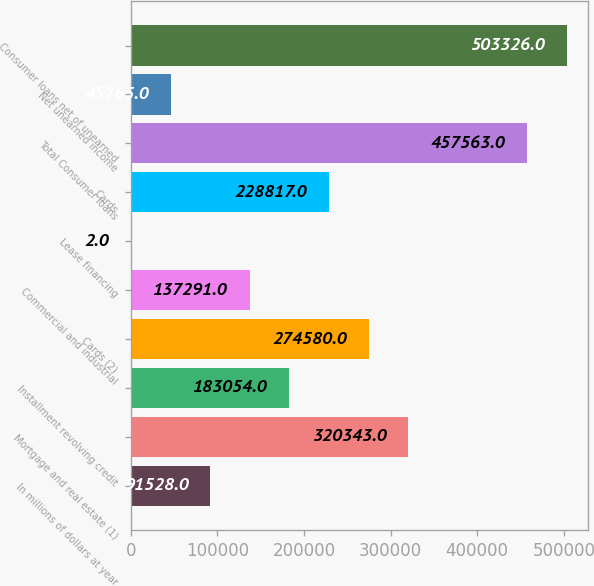<chart> <loc_0><loc_0><loc_500><loc_500><bar_chart><fcel>In millions of dollars at year<fcel>Mortgage and real estate (1)<fcel>Installment revolving credit<fcel>Cards (2)<fcel>Commercial and industrial<fcel>Lease financing<fcel>Cards<fcel>Total Consumer loans<fcel>Net unearned income<fcel>Consumer loans net of unearned<nl><fcel>91528<fcel>320343<fcel>183054<fcel>274580<fcel>137291<fcel>2<fcel>228817<fcel>457563<fcel>45765<fcel>503326<nl></chart> 